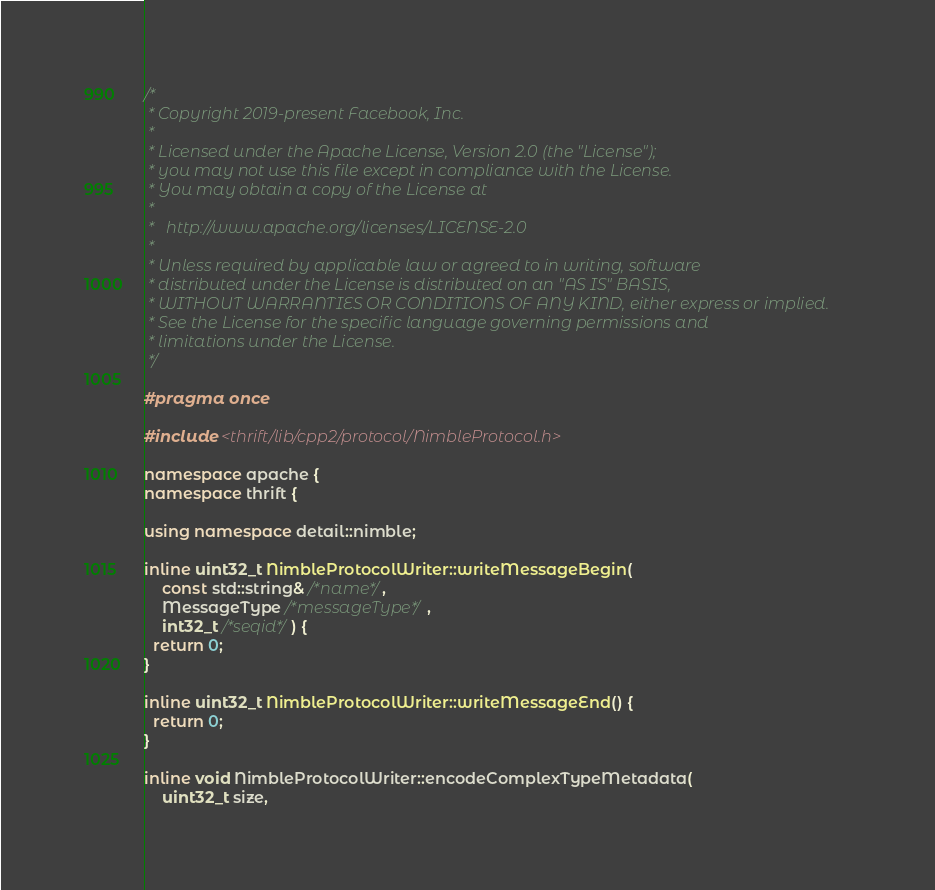Convert code to text. <code><loc_0><loc_0><loc_500><loc_500><_C++_>/*
 * Copyright 2019-present Facebook, Inc.
 *
 * Licensed under the Apache License, Version 2.0 (the "License");
 * you may not use this file except in compliance with the License.
 * You may obtain a copy of the License at
 *
 *   http://www.apache.org/licenses/LICENSE-2.0
 *
 * Unless required by applicable law or agreed to in writing, software
 * distributed under the License is distributed on an "AS IS" BASIS,
 * WITHOUT WARRANTIES OR CONDITIONS OF ANY KIND, either express or implied.
 * See the License for the specific language governing permissions and
 * limitations under the License.
 */

#pragma once

#include <thrift/lib/cpp2/protocol/NimbleProtocol.h>

namespace apache {
namespace thrift {

using namespace detail::nimble;

inline uint32_t NimbleProtocolWriter::writeMessageBegin(
    const std::string& /*name*/,
    MessageType /*messageType*/,
    int32_t /*seqid*/) {
  return 0;
}

inline uint32_t NimbleProtocolWriter::writeMessageEnd() {
  return 0;
}

inline void NimbleProtocolWriter::encodeComplexTypeMetadata(
    uint32_t size,</code> 